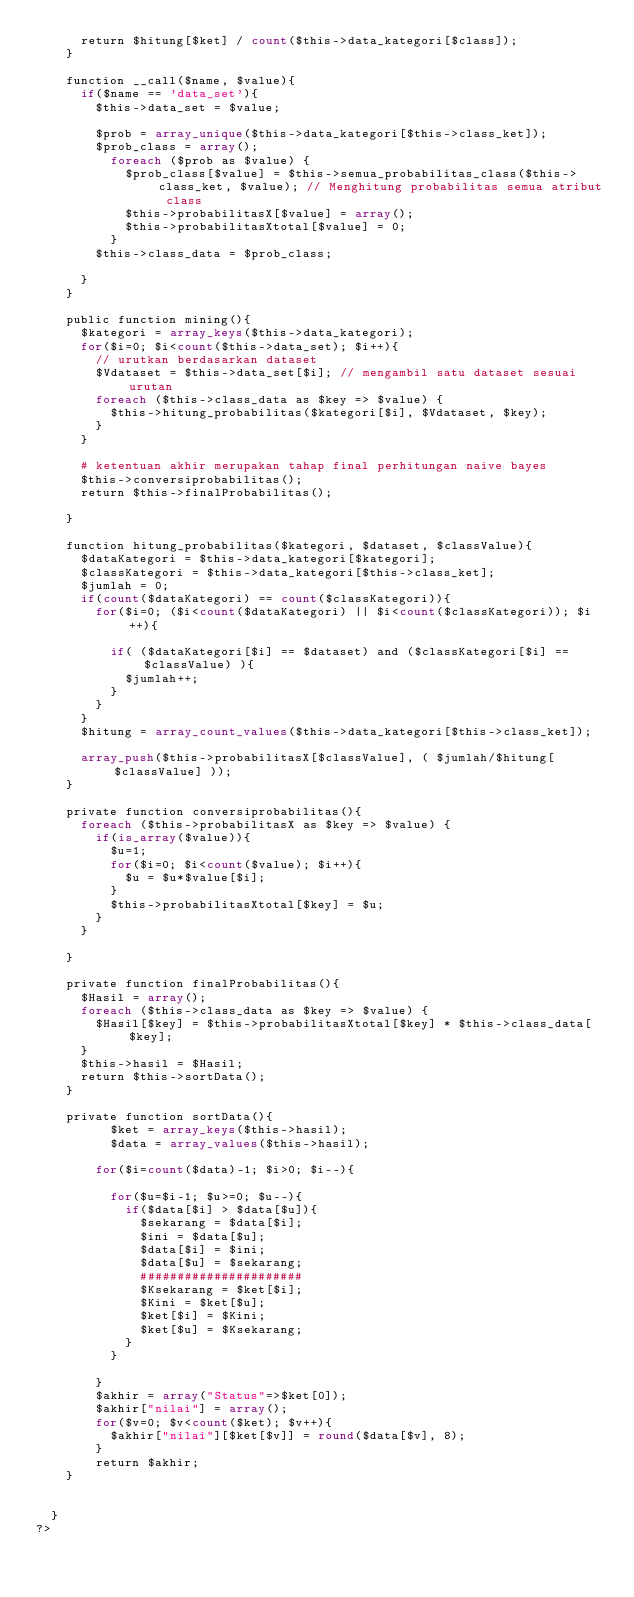Convert code to text. <code><loc_0><loc_0><loc_500><loc_500><_PHP_>			return $hitung[$ket] / count($this->data_kategori[$class]);
		}

		function __call($name, $value){
			if($name == 'data_set'){
				$this->data_set = $value;

				$prob = array_unique($this->data_kategori[$this->class_ket]);
				$prob_class = array();
					foreach ($prob as $value) {
						$prob_class[$value] = $this->semua_probabilitas_class($this->class_ket, $value); // Menghitung probabilitas semua atribut class
						$this->probabilitasX[$value] = array(); 
						$this->probabilitasXtotal[$value] = 0; 
					}
				$this->class_data = $prob_class;
				
			}
		}

		public function mining(){
			$kategori = array_keys($this->data_kategori);
			for($i=0; $i<count($this->data_set); $i++){
				// urutkan berdasarkan dataset
				$Vdataset = $this->data_set[$i]; // mengambil satu dataset sesuai urutan
				foreach ($this->class_data as $key => $value) {
					$this->hitung_probabilitas($kategori[$i], $Vdataset, $key);
				}
			}
			
			# ketentuan akhir merupakan tahap final perhitungan naive bayes
			$this->conversiprobabilitas();
			return $this->finalProbabilitas();

		}

		function hitung_probabilitas($kategori, $dataset, $classValue){
			$dataKategori = $this->data_kategori[$kategori];
			$classKategori = $this->data_kategori[$this->class_ket];
			$jumlah = 0;
			if(count($dataKategori) == count($classKategori)){
				for($i=0; ($i<count($dataKategori) || $i<count($classKategori)); $i++){
					
					if( ($dataKategori[$i] == $dataset) and ($classKategori[$i] == $classValue) ){
						$jumlah++;
					}
				}
			}
			$hitung = array_count_values($this->data_kategori[$this->class_ket]);

			array_push($this->probabilitasX[$classValue], ( $jumlah/$hitung[$classValue] ));
		}

		private function conversiprobabilitas(){
			foreach ($this->probabilitasX as $key => $value) {
				if(is_array($value)){
					$u=1;
					for($i=0; $i<count($value); $i++){
						$u = $u*$value[$i];
					}
					$this->probabilitasXtotal[$key] = $u;
				}
			}
			
		}

		private function finalProbabilitas(){
			$Hasil = array();
			foreach ($this->class_data as $key => $value) {
				$Hasil[$key] = $this->probabilitasXtotal[$key] * $this->class_data[$key];
			}
			$this->hasil = $Hasil;
			return $this->sortData();
		}

		private	function sortData(){
					$ket = array_keys($this->hasil);
					$data = array_values($this->hasil);
				
				for($i=count($data)-1; $i>0; $i--){
					
					for($u=$i-1; $u>=0; $u--){
						if($data[$i] > $data[$u]){
							$sekarang = $data[$i];
							$ini = $data[$u];
							$data[$i] = $ini;
							$data[$u] = $sekarang;
							######################
							$Ksekarang = $ket[$i];
							$Kini = $ket[$u];
							$ket[$i] = $Kini;
							$ket[$u] = $Ksekarang;
						}
					}
					
				}
				$akhir = array("Status"=>$ket[0]);
				$akhir["nilai"] = array();
				for($v=0; $v<count($ket); $v++){
					$akhir["nilai"][$ket[$v]] = round($data[$v], 8);
				}
				return $akhir;
		}
		
		
	}
?></code> 